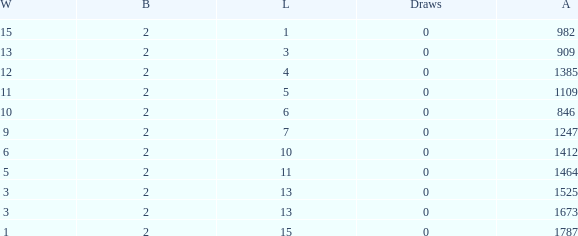What is the number listed under against when there were less than 13 losses and less than 2 byes? 0.0. 